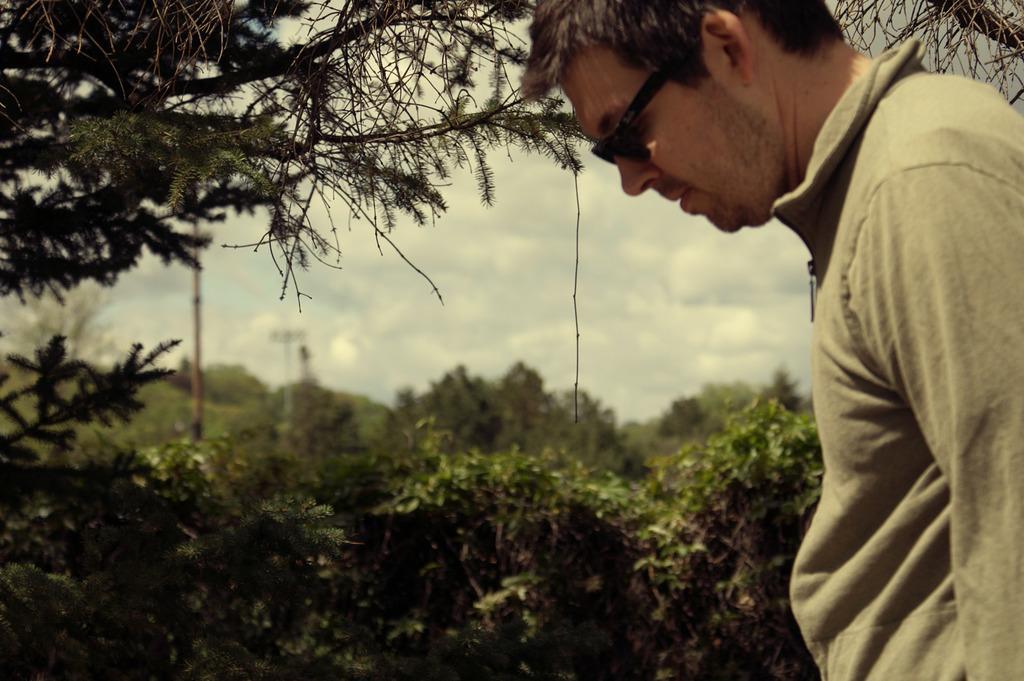In one or two sentences, can you explain what this image depicts? In this image I can see a person, trees, light poles and the sky. This image is taken may be in a forest. 